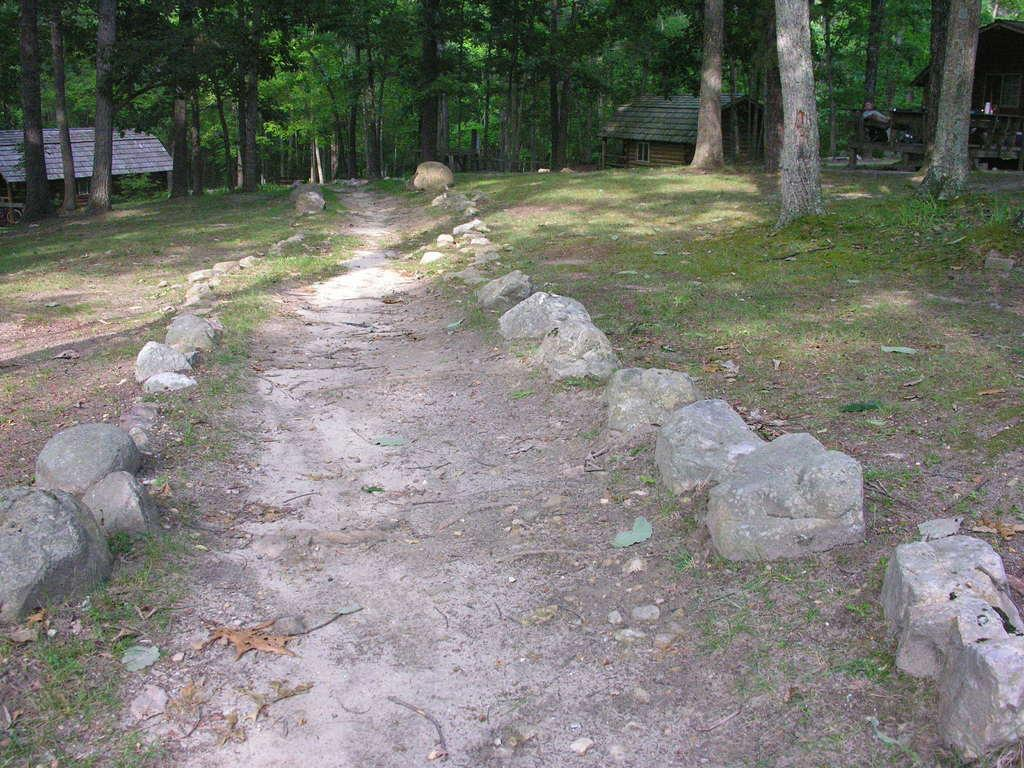What type of vegetation is present in the image? There is grass in the image. What else can be seen on the ground in the image? There are rocks on the ground in the image. What can be seen in the distance in the image? There are houses and trees in the background of the image. Can you describe any other objects in the background of the image? There are other unspecified objects in the background of the image. What type of doctor can be seen treating a chicken in the image? There is no doctor or chicken present in the image. How many men are visible in the image? There is no mention of men in the image, so it is not possible to determine their presence or number. 